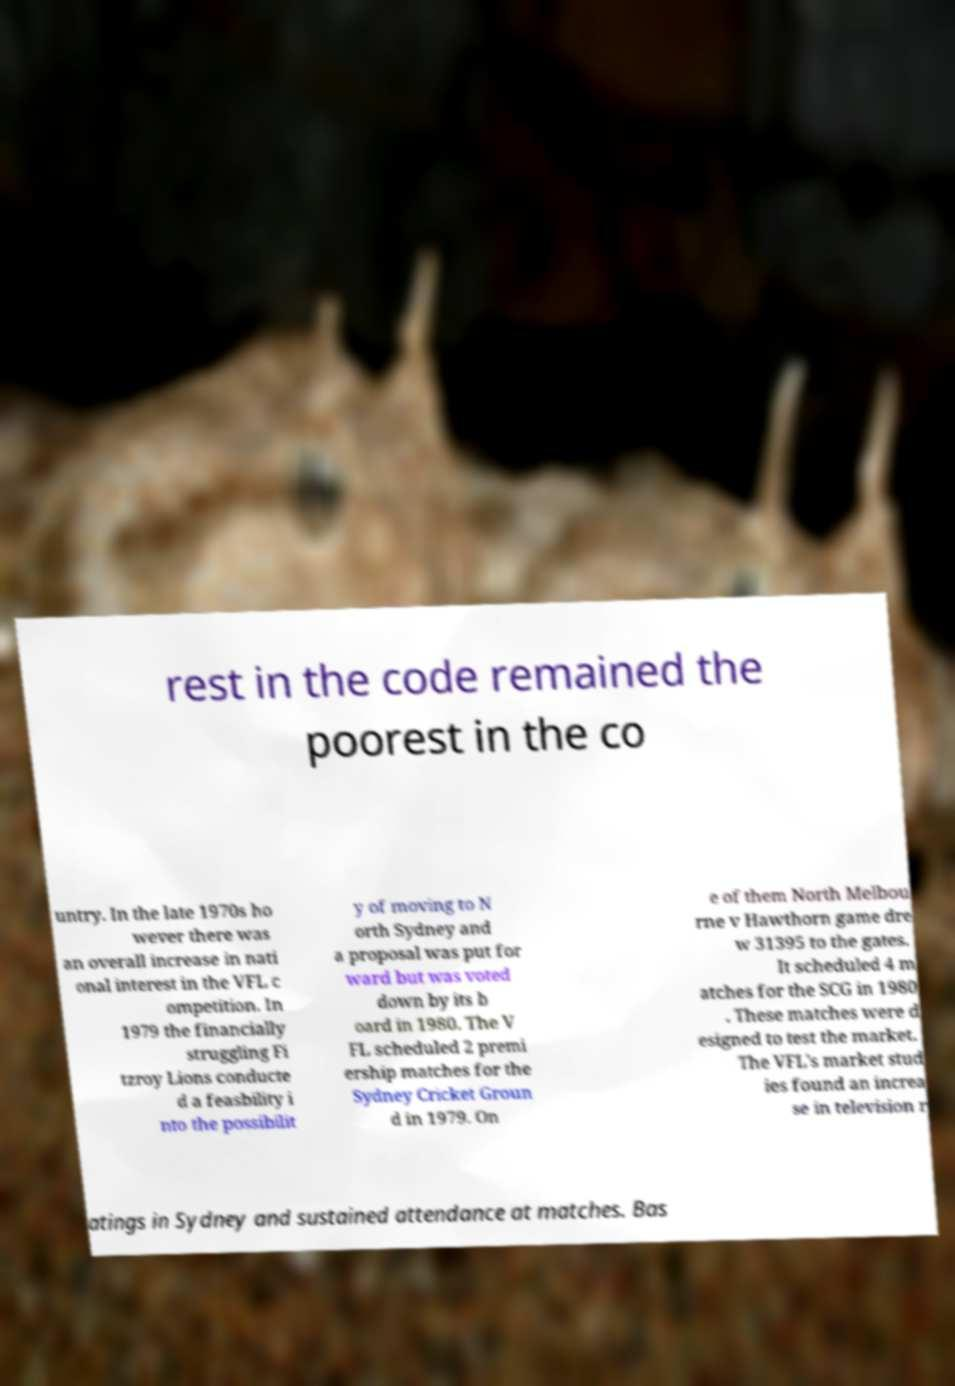I need the written content from this picture converted into text. Can you do that? rest in the code remained the poorest in the co untry. In the late 1970s ho wever there was an overall increase in nati onal interest in the VFL c ompetition. In 1979 the financially struggling Fi tzroy Lions conducte d a feasbility i nto the possibilit y of moving to N orth Sydney and a proposal was put for ward but was voted down by its b oard in 1980. The V FL scheduled 2 premi ership matches for the Sydney Cricket Groun d in 1979. On e of them North Melbou rne v Hawthorn game dre w 31395 to the gates. It scheduled 4 m atches for the SCG in 1980 . These matches were d esigned to test the market. The VFL's market stud ies found an increa se in television r atings in Sydney and sustained attendance at matches. Bas 